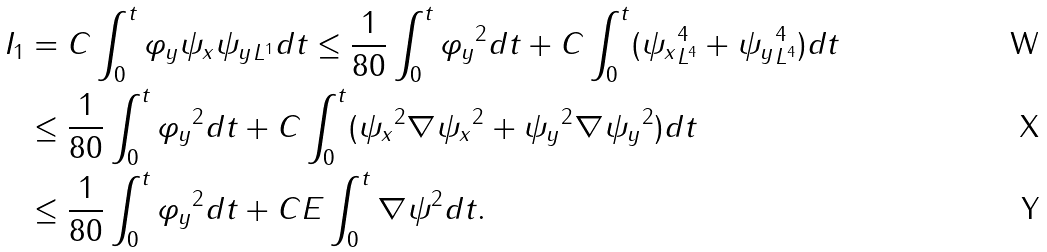<formula> <loc_0><loc_0><loc_500><loc_500>I _ { 1 } & = C \int _ { 0 } ^ { t } \| \varphi _ { y } \psi _ { x } \psi _ { y } \| _ { L ^ { 1 } } d t \leq \frac { 1 } { 8 0 } \int _ { 0 } ^ { t } \| \varphi _ { y } \| ^ { 2 } d t + C \int _ { 0 } ^ { t } ( \| \psi _ { x } \| _ { L ^ { 4 } } ^ { 4 } + \| \psi _ { y } \| _ { L ^ { 4 } } ^ { 4 } ) d t \\ & \leq \frac { 1 } { 8 0 } \int _ { 0 } ^ { t } \| \varphi _ { y } \| ^ { 2 } d t + C \int _ { 0 } ^ { t } ( \| \psi _ { x } \| ^ { 2 } \| \nabla \psi _ { x } \| ^ { 2 } + \| \psi _ { y } \| ^ { 2 } \| \nabla \psi _ { y } \| ^ { 2 } ) d t \\ & \leq \frac { 1 } { 8 0 } \int _ { 0 } ^ { t } \| \varphi _ { y } \| ^ { 2 } d t + C E \int _ { 0 } ^ { t } \| \nabla \psi \| ^ { 2 } d t .</formula> 